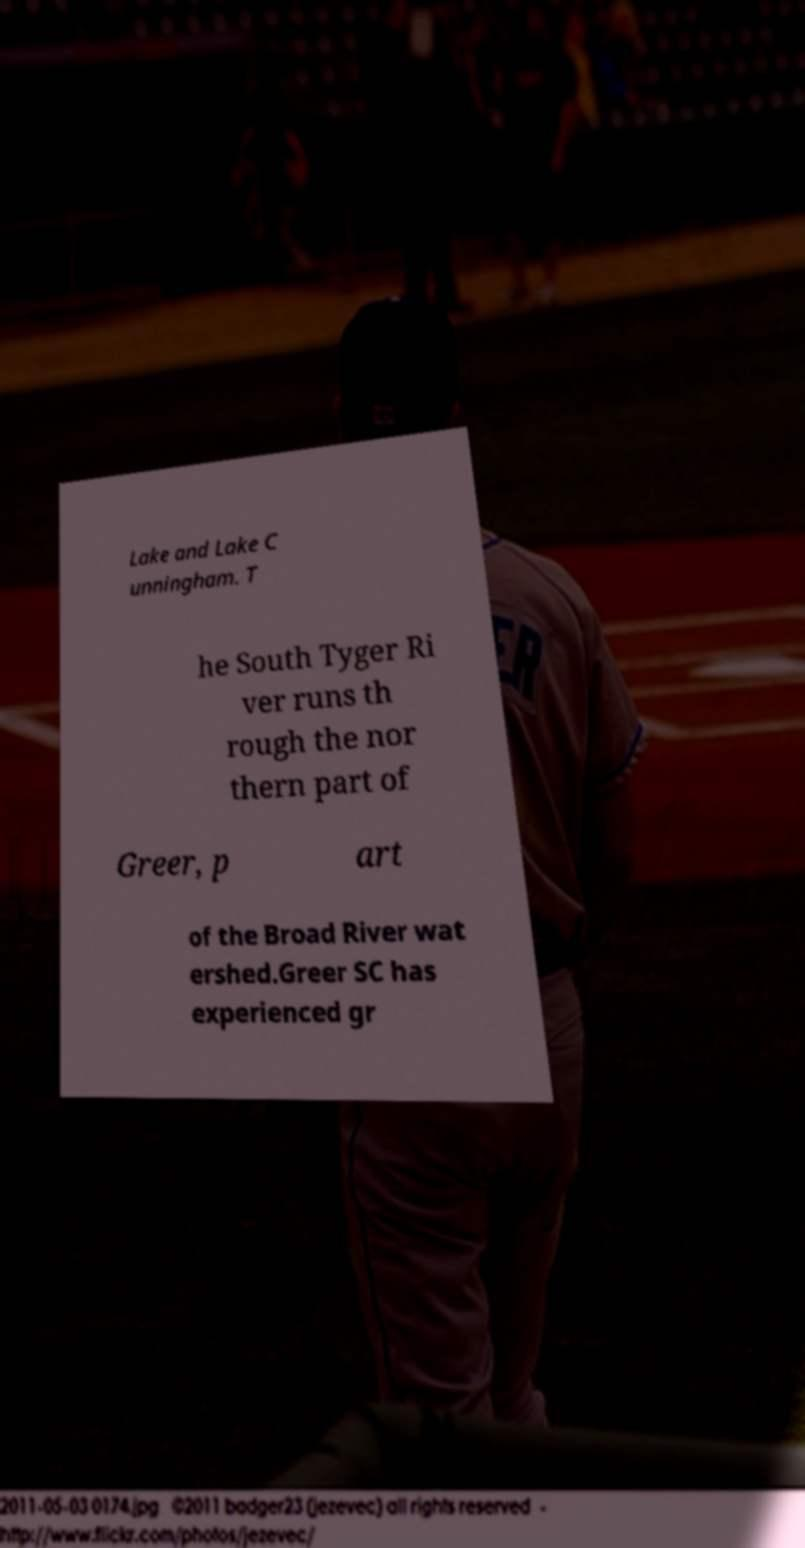Can you read and provide the text displayed in the image?This photo seems to have some interesting text. Can you extract and type it out for me? Lake and Lake C unningham. T he South Tyger Ri ver runs th rough the nor thern part of Greer, p art of the Broad River wat ershed.Greer SC has experienced gr 